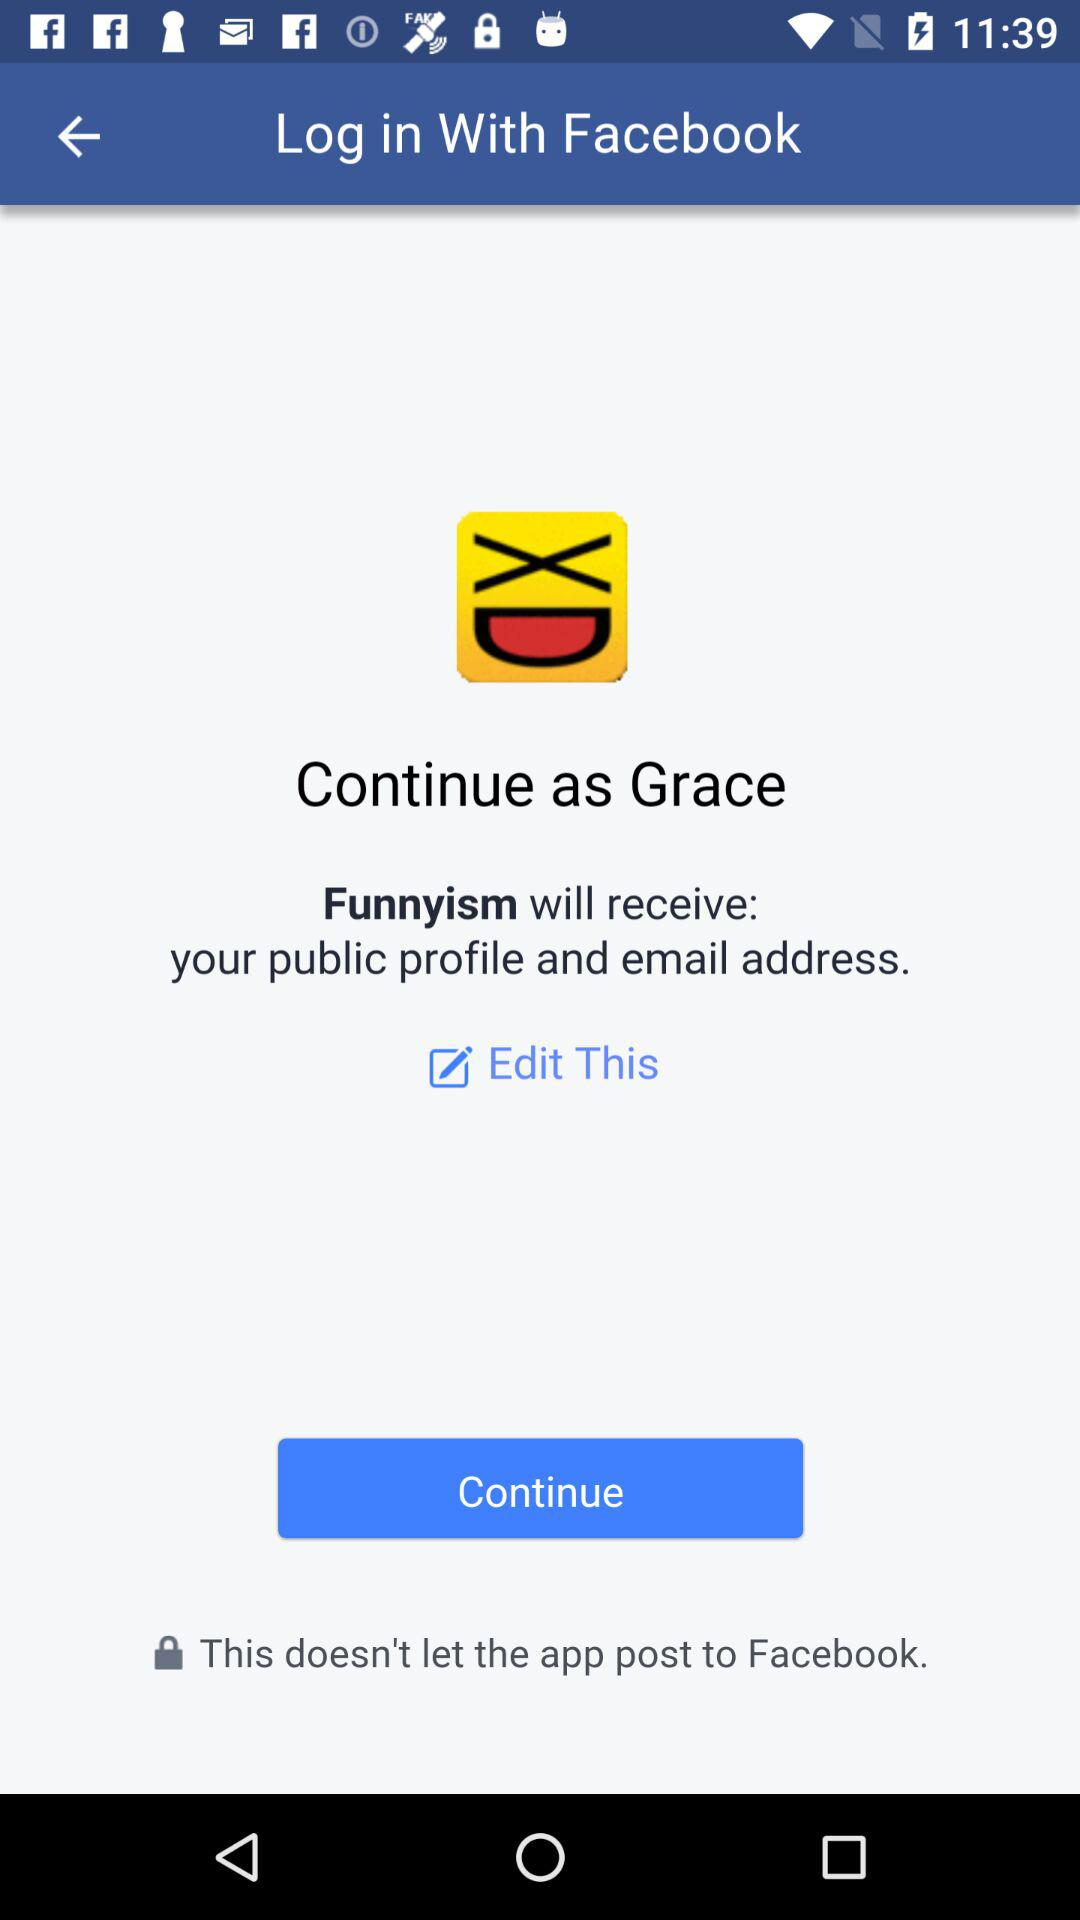What application is used to login? The application is Facebook. 